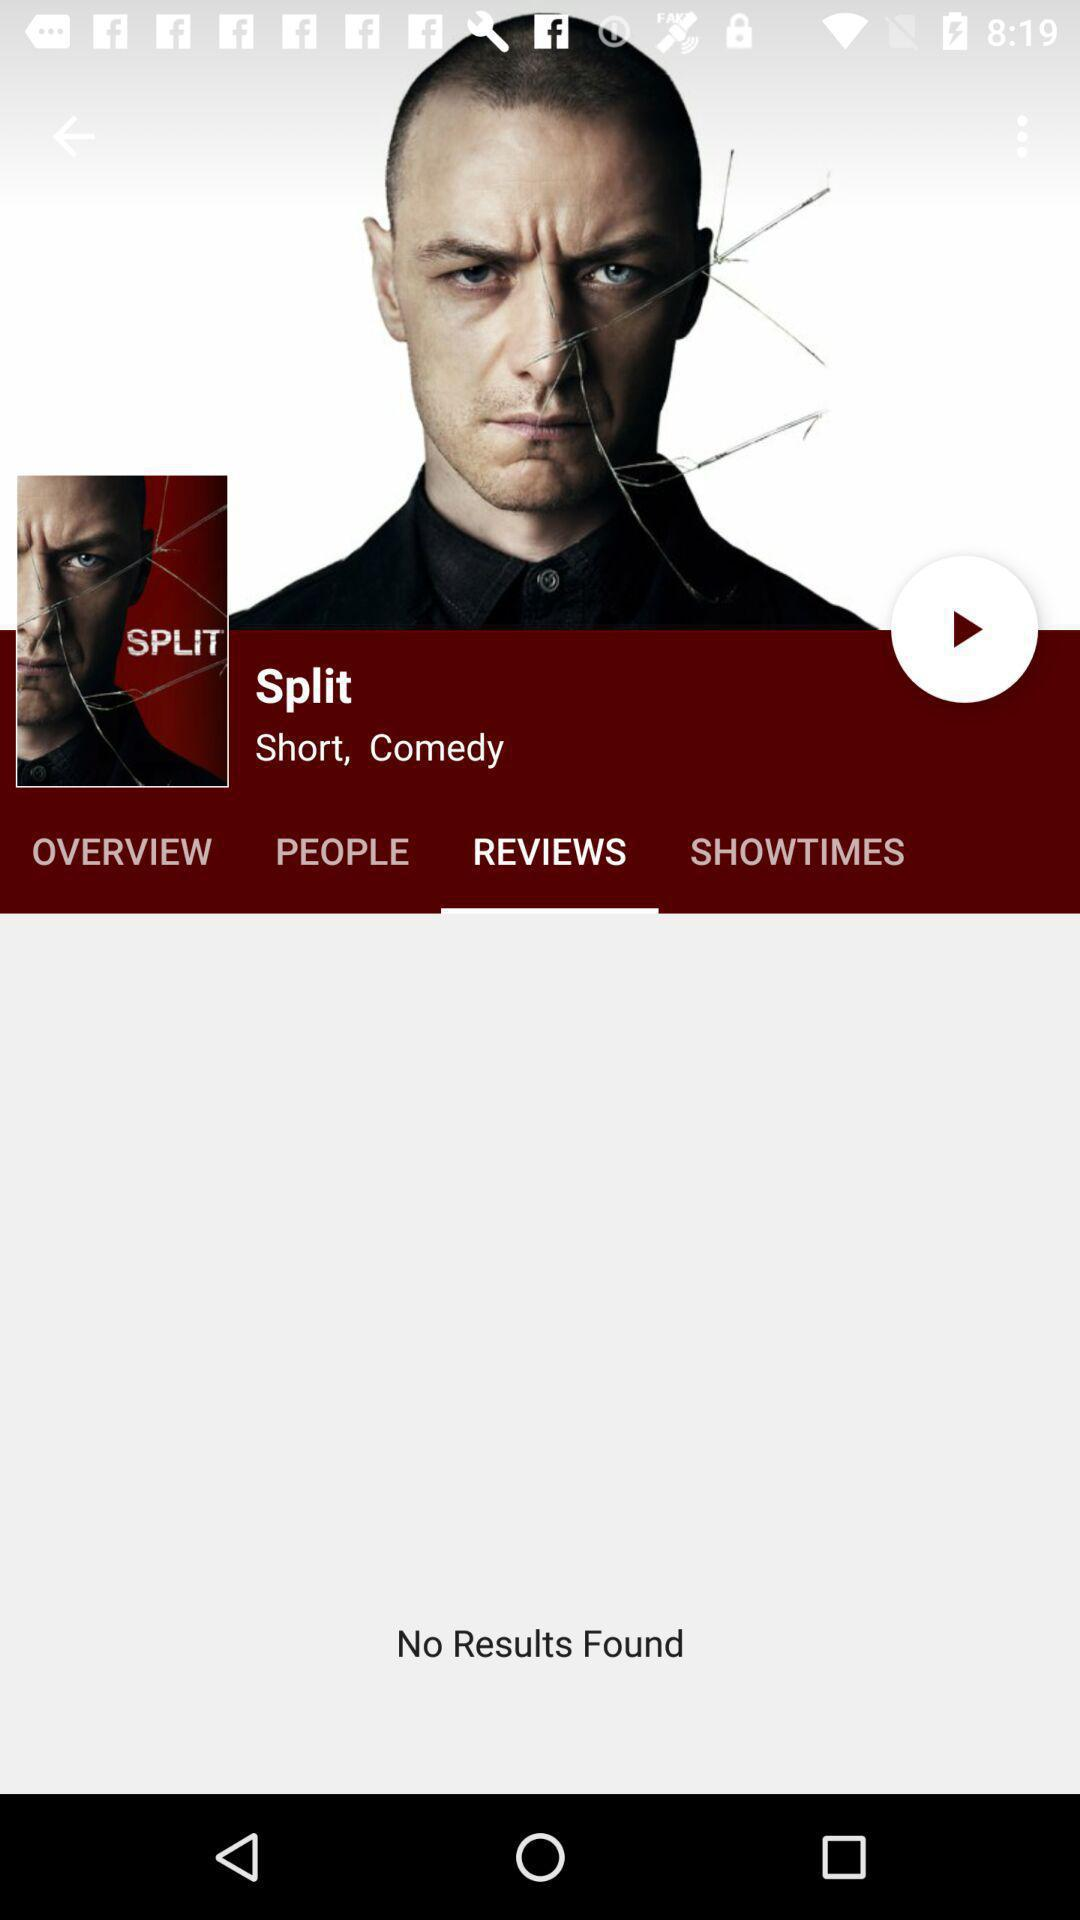What is the genre of the movie displayed? The genre is "Short, Comedy". 